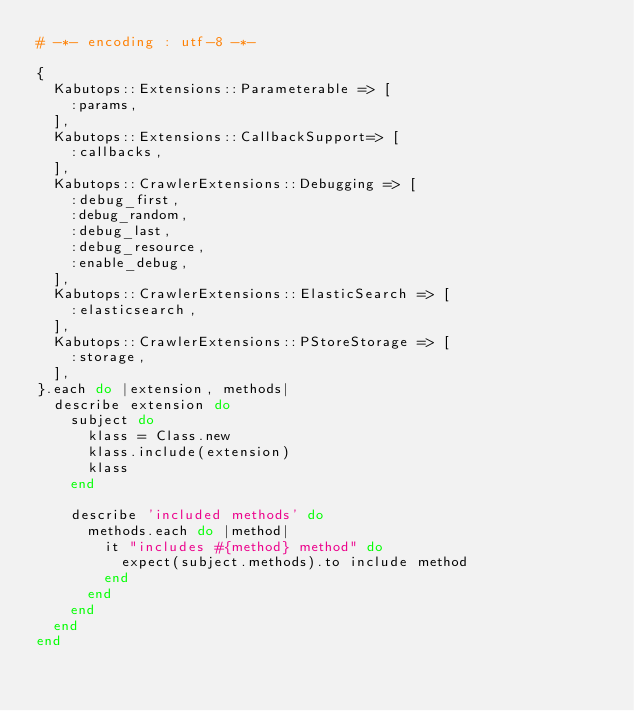Convert code to text. <code><loc_0><loc_0><loc_500><loc_500><_Ruby_># -*- encoding : utf-8 -*-

{
  Kabutops::Extensions::Parameterable => [
    :params,
  ],
  Kabutops::Extensions::CallbackSupport=> [
    :callbacks,
  ],
  Kabutops::CrawlerExtensions::Debugging => [
    :debug_first,
    :debug_random,
    :debug_last,
    :debug_resource,
    :enable_debug,
  ],
  Kabutops::CrawlerExtensions::ElasticSearch => [
    :elasticsearch,
  ],
  Kabutops::CrawlerExtensions::PStoreStorage => [
    :storage,
  ],
}.each do |extension, methods|
  describe extension do
    subject do
      klass = Class.new
      klass.include(extension)
      klass
    end

    describe 'included methods' do
      methods.each do |method|
        it "includes #{method} method" do
          expect(subject.methods).to include method
        end
      end
    end
  end
end
</code> 